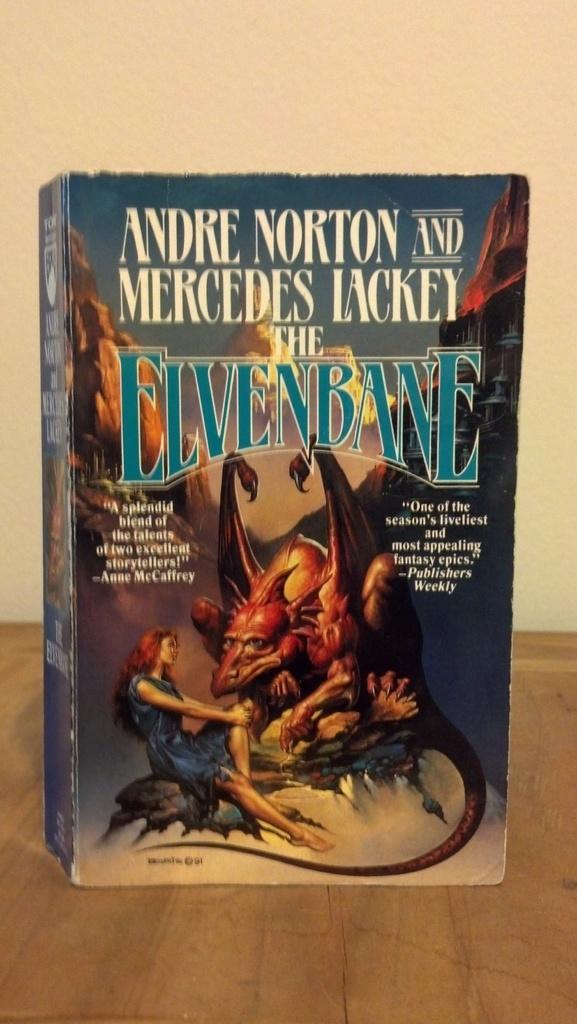In one or two sentences, can you explain what this image depicts? In this image there is a book with some text and images on it. 